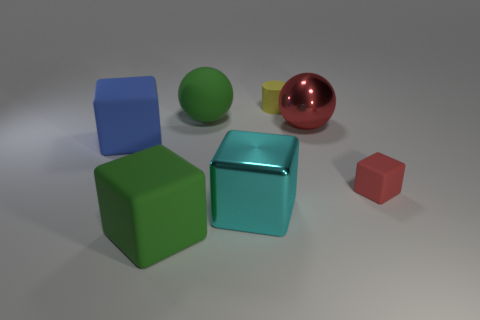The big rubber block behind the big matte thing that is in front of the small matte thing right of the large shiny sphere is what color?
Your answer should be compact. Blue. Is there a blue matte object that has the same shape as the big cyan object?
Your response must be concise. Yes. What number of big red metallic spheres are there?
Provide a succinct answer. 1. What shape is the big cyan object?
Provide a short and direct response. Cube. What number of shiny cylinders have the same size as the blue rubber block?
Your response must be concise. 0. Is the small red rubber thing the same shape as the blue matte object?
Make the answer very short. Yes. There is a matte object that is left of the rubber object in front of the tiny rubber cube; what color is it?
Offer a terse response. Blue. There is a matte block that is both to the left of the large red object and behind the cyan metal block; what is its size?
Give a very brief answer. Large. Is there anything else that has the same color as the big metal ball?
Provide a short and direct response. Yes. What is the shape of the yellow object that is made of the same material as the large green block?
Your response must be concise. Cylinder. 